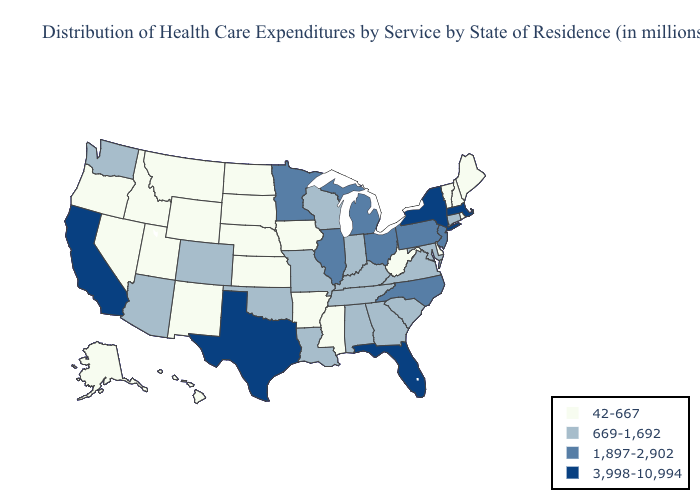Does Florida have the lowest value in the South?
Write a very short answer. No. Does Connecticut have the highest value in the Northeast?
Answer briefly. No. Does Idaho have a lower value than West Virginia?
Give a very brief answer. No. Name the states that have a value in the range 669-1,692?
Keep it brief. Alabama, Arizona, Colorado, Connecticut, Georgia, Indiana, Kentucky, Louisiana, Maryland, Missouri, Oklahoma, South Carolina, Tennessee, Virginia, Washington, Wisconsin. Name the states that have a value in the range 669-1,692?
Quick response, please. Alabama, Arizona, Colorado, Connecticut, Georgia, Indiana, Kentucky, Louisiana, Maryland, Missouri, Oklahoma, South Carolina, Tennessee, Virginia, Washington, Wisconsin. Does Ohio have the highest value in the MidWest?
Be succinct. Yes. Name the states that have a value in the range 669-1,692?
Write a very short answer. Alabama, Arizona, Colorado, Connecticut, Georgia, Indiana, Kentucky, Louisiana, Maryland, Missouri, Oklahoma, South Carolina, Tennessee, Virginia, Washington, Wisconsin. What is the lowest value in states that border Connecticut?
Concise answer only. 42-667. Which states have the lowest value in the USA?
Keep it brief. Alaska, Arkansas, Delaware, Hawaii, Idaho, Iowa, Kansas, Maine, Mississippi, Montana, Nebraska, Nevada, New Hampshire, New Mexico, North Dakota, Oregon, Rhode Island, South Dakota, Utah, Vermont, West Virginia, Wyoming. Among the states that border Maryland , which have the highest value?
Answer briefly. Pennsylvania. What is the value of Ohio?
Answer briefly. 1,897-2,902. Among the states that border Maine , which have the lowest value?
Write a very short answer. New Hampshire. Name the states that have a value in the range 1,897-2,902?
Write a very short answer. Illinois, Michigan, Minnesota, New Jersey, North Carolina, Ohio, Pennsylvania. Name the states that have a value in the range 669-1,692?
Write a very short answer. Alabama, Arizona, Colorado, Connecticut, Georgia, Indiana, Kentucky, Louisiana, Maryland, Missouri, Oklahoma, South Carolina, Tennessee, Virginia, Washington, Wisconsin. Does Kentucky have a lower value than Kansas?
Keep it brief. No. 